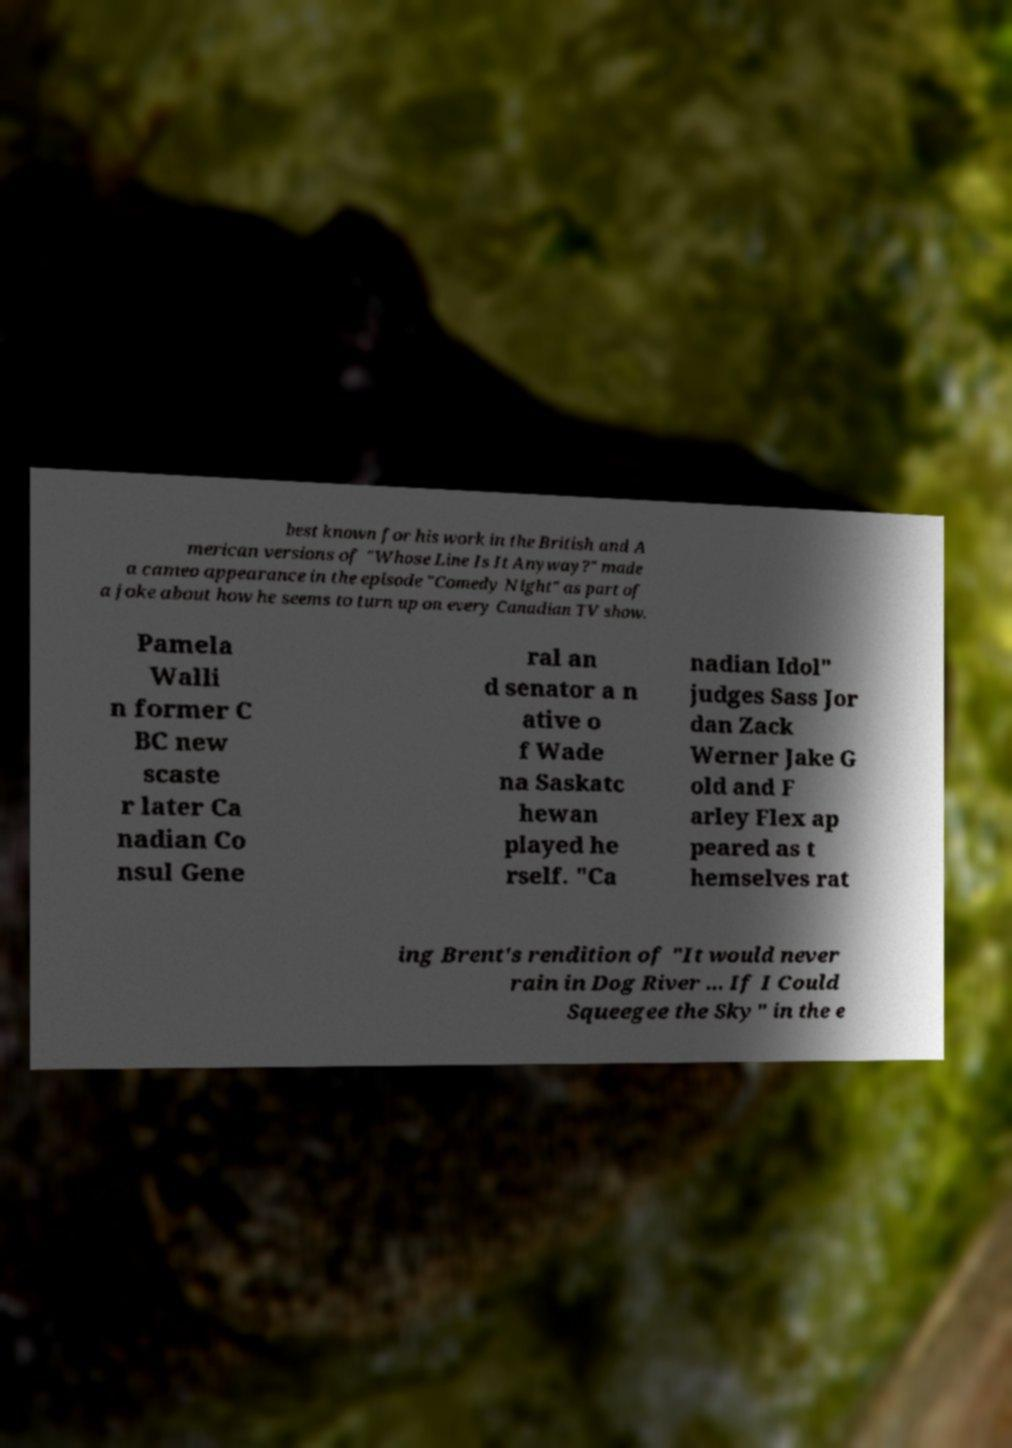Can you read and provide the text displayed in the image?This photo seems to have some interesting text. Can you extract and type it out for me? best known for his work in the British and A merican versions of "Whose Line Is It Anyway?" made a cameo appearance in the episode "Comedy Night" as part of a joke about how he seems to turn up on every Canadian TV show. Pamela Walli n former C BC new scaste r later Ca nadian Co nsul Gene ral an d senator a n ative o f Wade na Saskatc hewan played he rself. "Ca nadian Idol" judges Sass Jor dan Zack Werner Jake G old and F arley Flex ap peared as t hemselves rat ing Brent's rendition of "It would never rain in Dog River ... If I Could Squeegee the Sky" in the e 